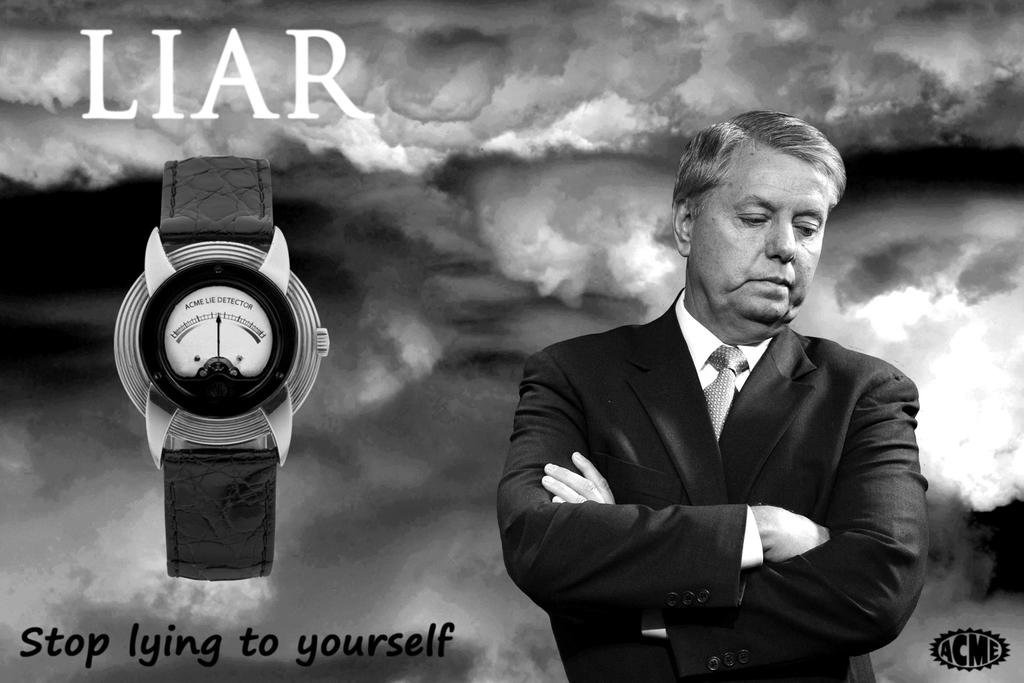Provide a one-sentence caption for the provided image. A guy looks sad with a watch next to him and it say Liar. 